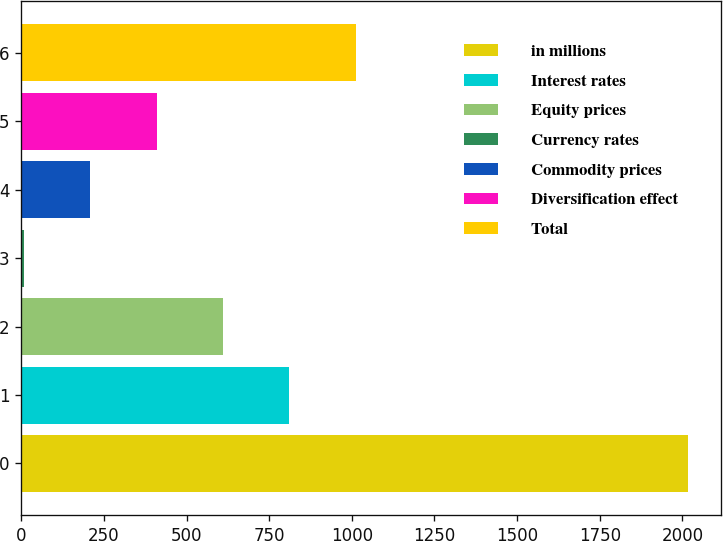Convert chart to OTSL. <chart><loc_0><loc_0><loc_500><loc_500><bar_chart><fcel>in millions<fcel>Interest rates<fcel>Equity prices<fcel>Currency rates<fcel>Commodity prices<fcel>Diversification effect<fcel>Total<nl><fcel>2017<fcel>811<fcel>610<fcel>7<fcel>208<fcel>409<fcel>1012<nl></chart> 